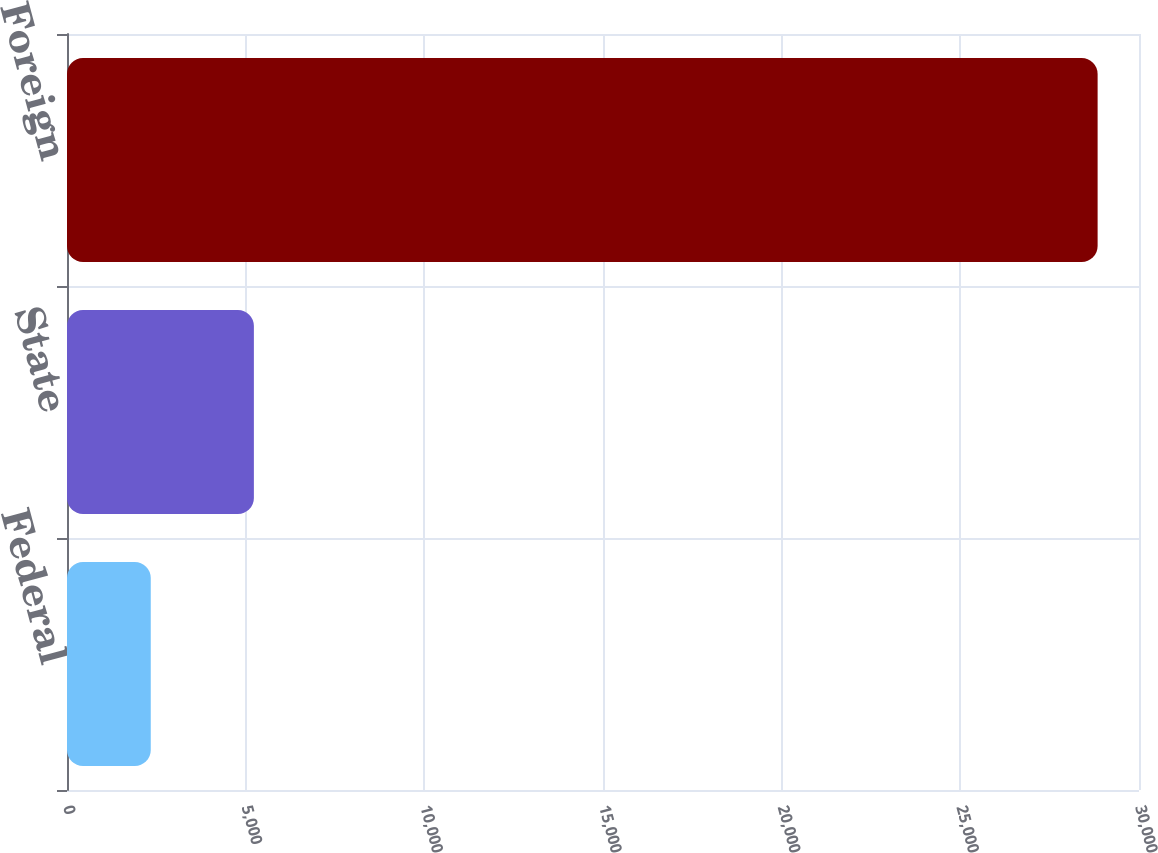Convert chart. <chart><loc_0><loc_0><loc_500><loc_500><bar_chart><fcel>Federal<fcel>State<fcel>Foreign<nl><fcel>2344<fcel>5230<fcel>28842<nl></chart> 